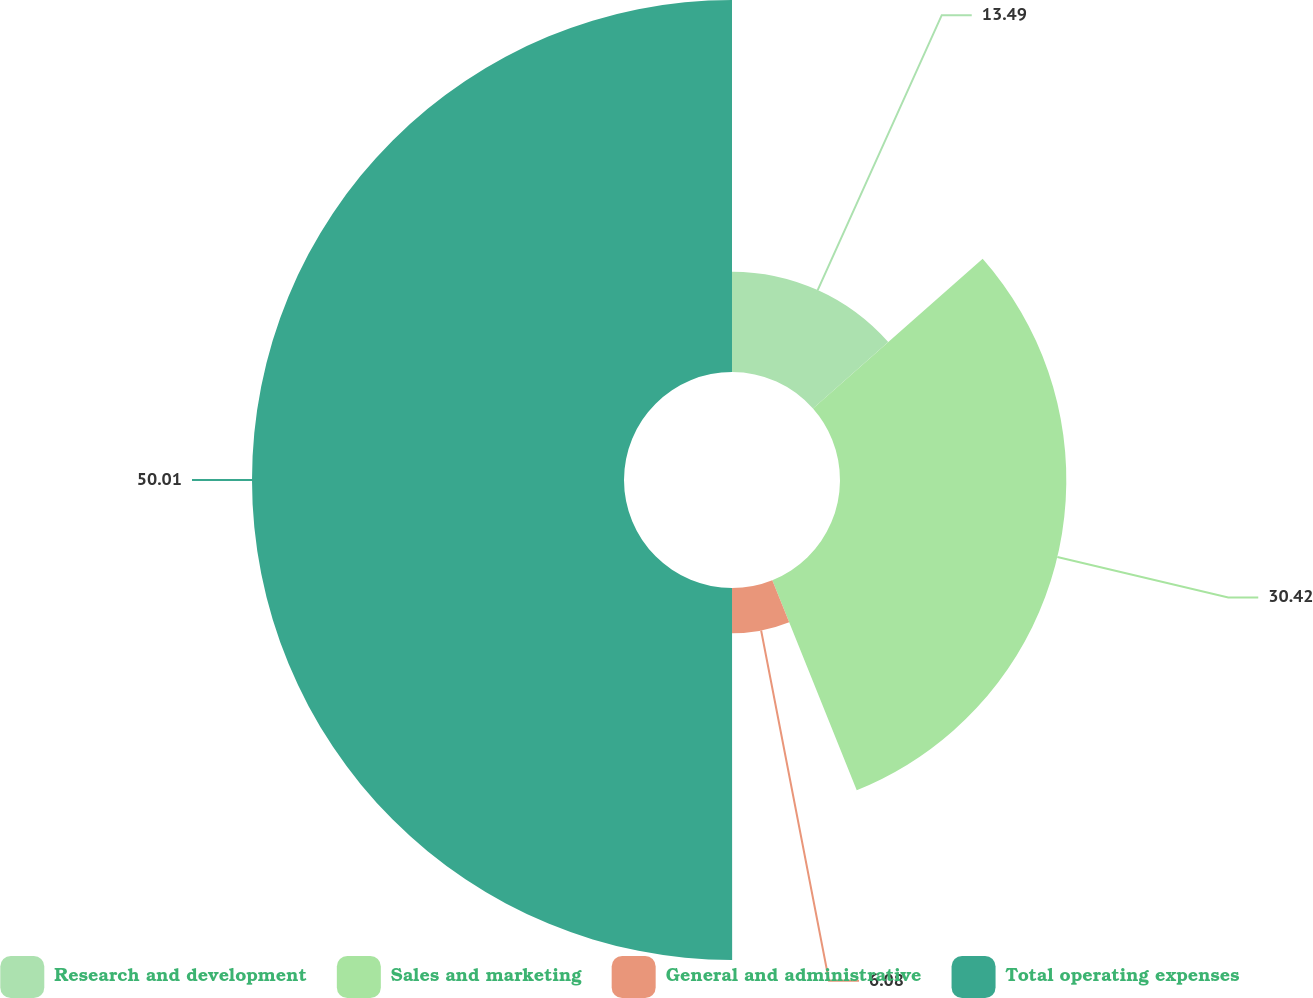<chart> <loc_0><loc_0><loc_500><loc_500><pie_chart><fcel>Research and development<fcel>Sales and marketing<fcel>General and administrative<fcel>Total operating expenses<nl><fcel>13.49%<fcel>30.42%<fcel>6.08%<fcel>50.0%<nl></chart> 